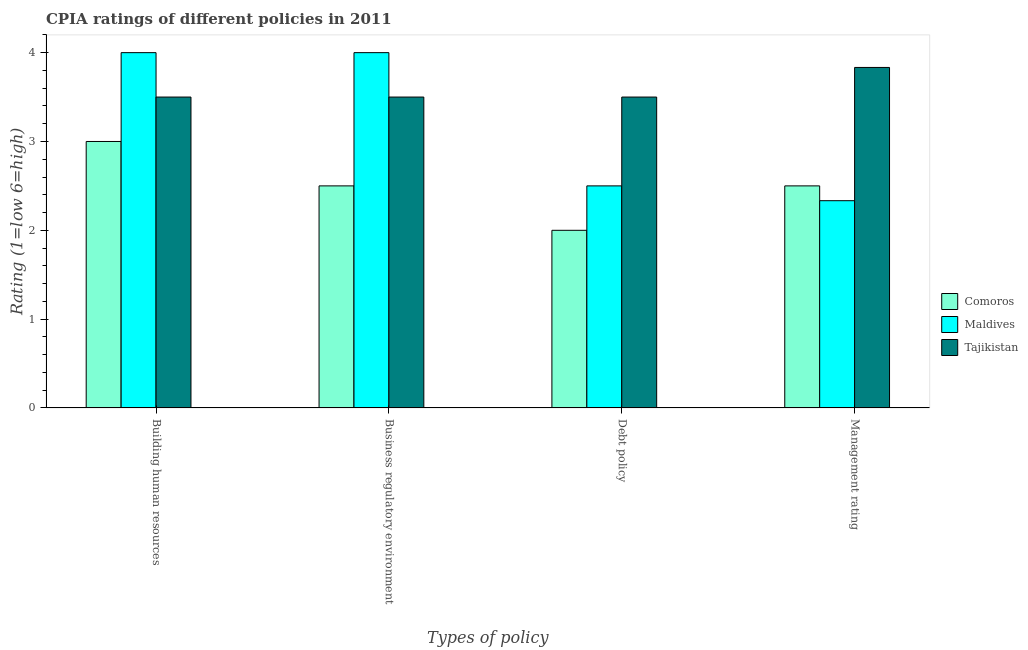How many different coloured bars are there?
Your answer should be compact. 3. Are the number of bars per tick equal to the number of legend labels?
Ensure brevity in your answer.  Yes. Are the number of bars on each tick of the X-axis equal?
Offer a terse response. Yes. How many bars are there on the 3rd tick from the left?
Make the answer very short. 3. How many bars are there on the 2nd tick from the right?
Provide a succinct answer. 3. What is the label of the 4th group of bars from the left?
Ensure brevity in your answer.  Management rating. What is the cpia rating of building human resources in Tajikistan?
Provide a short and direct response. 3.5. Across all countries, what is the maximum cpia rating of debt policy?
Your response must be concise. 3.5. Across all countries, what is the minimum cpia rating of debt policy?
Keep it short and to the point. 2. In which country was the cpia rating of debt policy maximum?
Your answer should be very brief. Tajikistan. In which country was the cpia rating of management minimum?
Your answer should be compact. Maldives. What is the difference between the cpia rating of business regulatory environment in Tajikistan and that in Comoros?
Offer a very short reply. 1. What is the ratio of the cpia rating of building human resources in Tajikistan to that in Maldives?
Keep it short and to the point. 0.88. What is the difference between the highest and the second highest cpia rating of management?
Provide a short and direct response. 1.33. Is the sum of the cpia rating of debt policy in Maldives and Tajikistan greater than the maximum cpia rating of business regulatory environment across all countries?
Your answer should be very brief. Yes. Is it the case that in every country, the sum of the cpia rating of management and cpia rating of building human resources is greater than the sum of cpia rating of debt policy and cpia rating of business regulatory environment?
Give a very brief answer. No. What does the 1st bar from the left in Management rating represents?
Keep it short and to the point. Comoros. What does the 3rd bar from the right in Building human resources represents?
Your answer should be compact. Comoros. Is it the case that in every country, the sum of the cpia rating of building human resources and cpia rating of business regulatory environment is greater than the cpia rating of debt policy?
Make the answer very short. Yes. What is the difference between two consecutive major ticks on the Y-axis?
Your answer should be very brief. 1. Are the values on the major ticks of Y-axis written in scientific E-notation?
Offer a very short reply. No. Where does the legend appear in the graph?
Offer a very short reply. Center right. How are the legend labels stacked?
Provide a short and direct response. Vertical. What is the title of the graph?
Your answer should be very brief. CPIA ratings of different policies in 2011. What is the label or title of the X-axis?
Ensure brevity in your answer.  Types of policy. What is the Rating (1=low 6=high) in Comoros in Building human resources?
Offer a very short reply. 3. What is the Rating (1=low 6=high) in Maldives in Building human resources?
Keep it short and to the point. 4. What is the Rating (1=low 6=high) of Tajikistan in Building human resources?
Give a very brief answer. 3.5. What is the Rating (1=low 6=high) of Maldives in Debt policy?
Your answer should be very brief. 2.5. What is the Rating (1=low 6=high) of Tajikistan in Debt policy?
Your answer should be very brief. 3.5. What is the Rating (1=low 6=high) of Comoros in Management rating?
Offer a terse response. 2.5. What is the Rating (1=low 6=high) of Maldives in Management rating?
Keep it short and to the point. 2.33. What is the Rating (1=low 6=high) in Tajikistan in Management rating?
Your response must be concise. 3.83. Across all Types of policy, what is the maximum Rating (1=low 6=high) of Comoros?
Make the answer very short. 3. Across all Types of policy, what is the maximum Rating (1=low 6=high) in Maldives?
Your answer should be very brief. 4. Across all Types of policy, what is the maximum Rating (1=low 6=high) in Tajikistan?
Your response must be concise. 3.83. Across all Types of policy, what is the minimum Rating (1=low 6=high) of Comoros?
Keep it short and to the point. 2. Across all Types of policy, what is the minimum Rating (1=low 6=high) in Maldives?
Provide a short and direct response. 2.33. Across all Types of policy, what is the minimum Rating (1=low 6=high) of Tajikistan?
Offer a very short reply. 3.5. What is the total Rating (1=low 6=high) of Maldives in the graph?
Keep it short and to the point. 12.83. What is the total Rating (1=low 6=high) of Tajikistan in the graph?
Offer a terse response. 14.33. What is the difference between the Rating (1=low 6=high) of Tajikistan in Building human resources and that in Business regulatory environment?
Provide a succinct answer. 0. What is the difference between the Rating (1=low 6=high) in Maldives in Building human resources and that in Debt policy?
Provide a succinct answer. 1.5. What is the difference between the Rating (1=low 6=high) in Tajikistan in Building human resources and that in Debt policy?
Your response must be concise. 0. What is the difference between the Rating (1=low 6=high) of Maldives in Building human resources and that in Management rating?
Make the answer very short. 1.67. What is the difference between the Rating (1=low 6=high) in Comoros in Business regulatory environment and that in Debt policy?
Ensure brevity in your answer.  0.5. What is the difference between the Rating (1=low 6=high) of Comoros in Business regulatory environment and that in Management rating?
Your answer should be very brief. 0. What is the difference between the Rating (1=low 6=high) in Maldives in Business regulatory environment and that in Management rating?
Provide a short and direct response. 1.67. What is the difference between the Rating (1=low 6=high) in Comoros in Debt policy and that in Management rating?
Offer a terse response. -0.5. What is the difference between the Rating (1=low 6=high) of Comoros in Building human resources and the Rating (1=low 6=high) of Maldives in Business regulatory environment?
Make the answer very short. -1. What is the difference between the Rating (1=low 6=high) of Comoros in Building human resources and the Rating (1=low 6=high) of Tajikistan in Business regulatory environment?
Offer a very short reply. -0.5. What is the difference between the Rating (1=low 6=high) in Comoros in Building human resources and the Rating (1=low 6=high) in Tajikistan in Debt policy?
Offer a very short reply. -0.5. What is the difference between the Rating (1=low 6=high) of Comoros in Building human resources and the Rating (1=low 6=high) of Tajikistan in Management rating?
Make the answer very short. -0.83. What is the difference between the Rating (1=low 6=high) in Maldives in Building human resources and the Rating (1=low 6=high) in Tajikistan in Management rating?
Your answer should be compact. 0.17. What is the difference between the Rating (1=low 6=high) of Comoros in Business regulatory environment and the Rating (1=low 6=high) of Maldives in Debt policy?
Give a very brief answer. 0. What is the difference between the Rating (1=low 6=high) of Maldives in Business regulatory environment and the Rating (1=low 6=high) of Tajikistan in Debt policy?
Keep it short and to the point. 0.5. What is the difference between the Rating (1=low 6=high) in Comoros in Business regulatory environment and the Rating (1=low 6=high) in Maldives in Management rating?
Your answer should be compact. 0.17. What is the difference between the Rating (1=low 6=high) in Comoros in Business regulatory environment and the Rating (1=low 6=high) in Tajikistan in Management rating?
Your answer should be compact. -1.33. What is the difference between the Rating (1=low 6=high) of Comoros in Debt policy and the Rating (1=low 6=high) of Maldives in Management rating?
Keep it short and to the point. -0.33. What is the difference between the Rating (1=low 6=high) of Comoros in Debt policy and the Rating (1=low 6=high) of Tajikistan in Management rating?
Make the answer very short. -1.83. What is the difference between the Rating (1=low 6=high) in Maldives in Debt policy and the Rating (1=low 6=high) in Tajikistan in Management rating?
Offer a very short reply. -1.33. What is the average Rating (1=low 6=high) in Maldives per Types of policy?
Offer a terse response. 3.21. What is the average Rating (1=low 6=high) of Tajikistan per Types of policy?
Your answer should be very brief. 3.58. What is the difference between the Rating (1=low 6=high) of Comoros and Rating (1=low 6=high) of Maldives in Building human resources?
Provide a short and direct response. -1. What is the difference between the Rating (1=low 6=high) of Comoros and Rating (1=low 6=high) of Tajikistan in Building human resources?
Give a very brief answer. -0.5. What is the difference between the Rating (1=low 6=high) of Comoros and Rating (1=low 6=high) of Tajikistan in Business regulatory environment?
Offer a very short reply. -1. What is the difference between the Rating (1=low 6=high) of Comoros and Rating (1=low 6=high) of Maldives in Debt policy?
Your answer should be very brief. -0.5. What is the difference between the Rating (1=low 6=high) of Comoros and Rating (1=low 6=high) of Tajikistan in Debt policy?
Provide a short and direct response. -1.5. What is the difference between the Rating (1=low 6=high) in Maldives and Rating (1=low 6=high) in Tajikistan in Debt policy?
Provide a succinct answer. -1. What is the difference between the Rating (1=low 6=high) in Comoros and Rating (1=low 6=high) in Tajikistan in Management rating?
Your answer should be compact. -1.33. What is the difference between the Rating (1=low 6=high) of Maldives and Rating (1=low 6=high) of Tajikistan in Management rating?
Keep it short and to the point. -1.5. What is the ratio of the Rating (1=low 6=high) of Comoros in Building human resources to that in Business regulatory environment?
Your answer should be very brief. 1.2. What is the ratio of the Rating (1=low 6=high) of Tajikistan in Building human resources to that in Business regulatory environment?
Ensure brevity in your answer.  1. What is the ratio of the Rating (1=low 6=high) of Comoros in Building human resources to that in Debt policy?
Keep it short and to the point. 1.5. What is the ratio of the Rating (1=low 6=high) of Maldives in Building human resources to that in Debt policy?
Keep it short and to the point. 1.6. What is the ratio of the Rating (1=low 6=high) of Tajikistan in Building human resources to that in Debt policy?
Provide a short and direct response. 1. What is the ratio of the Rating (1=low 6=high) in Comoros in Building human resources to that in Management rating?
Your response must be concise. 1.2. What is the ratio of the Rating (1=low 6=high) in Maldives in Building human resources to that in Management rating?
Your response must be concise. 1.71. What is the ratio of the Rating (1=low 6=high) of Comoros in Business regulatory environment to that in Debt policy?
Keep it short and to the point. 1.25. What is the ratio of the Rating (1=low 6=high) in Maldives in Business regulatory environment to that in Management rating?
Your answer should be very brief. 1.71. What is the ratio of the Rating (1=low 6=high) of Maldives in Debt policy to that in Management rating?
Keep it short and to the point. 1.07. What is the ratio of the Rating (1=low 6=high) in Tajikistan in Debt policy to that in Management rating?
Provide a short and direct response. 0.91. What is the difference between the highest and the second highest Rating (1=low 6=high) in Maldives?
Ensure brevity in your answer.  0. What is the difference between the highest and the second highest Rating (1=low 6=high) in Tajikistan?
Your answer should be compact. 0.33. What is the difference between the highest and the lowest Rating (1=low 6=high) of Maldives?
Provide a short and direct response. 1.67. What is the difference between the highest and the lowest Rating (1=low 6=high) in Tajikistan?
Ensure brevity in your answer.  0.33. 